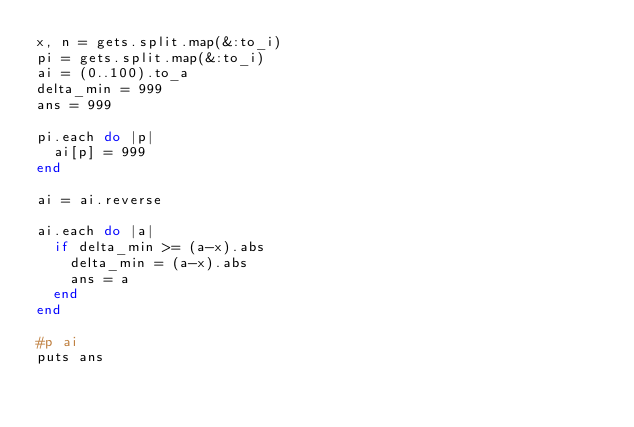Convert code to text. <code><loc_0><loc_0><loc_500><loc_500><_Ruby_>x, n = gets.split.map(&:to_i)
pi = gets.split.map(&:to_i)
ai = (0..100).to_a
delta_min = 999
ans = 999

pi.each do |p|
  ai[p] = 999
end

ai = ai.reverse

ai.each do |a|
  if delta_min >= (a-x).abs
    delta_min = (a-x).abs
    ans = a
  end
end

#p ai
puts ans
</code> 